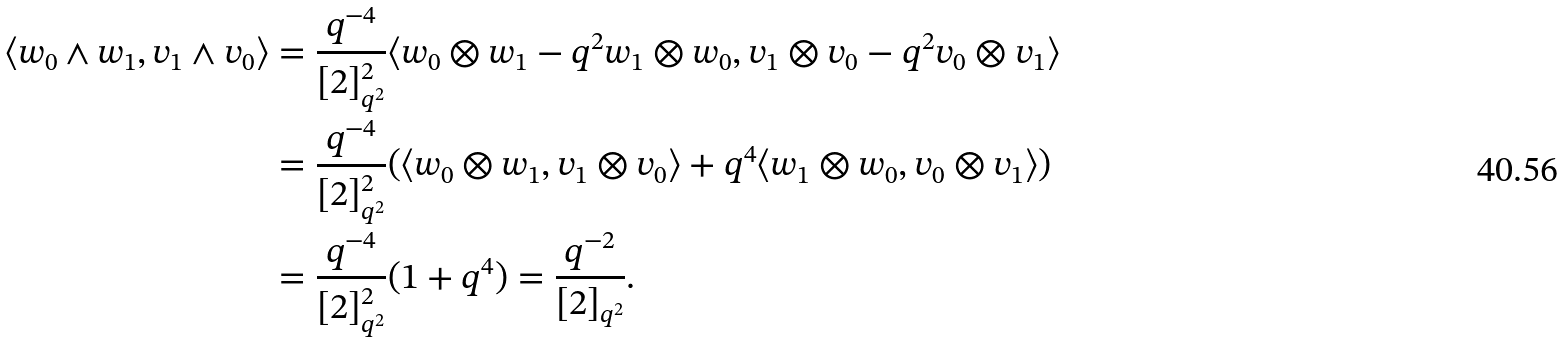<formula> <loc_0><loc_0><loc_500><loc_500>\langle w _ { 0 } \wedge w _ { 1 } , v _ { 1 } \wedge v _ { 0 } \rangle & = \frac { q ^ { - 4 } } { [ 2 ] ^ { 2 } _ { q ^ { 2 } } } \langle w _ { 0 } \otimes w _ { 1 } - q ^ { 2 } w _ { 1 } \otimes w _ { 0 } , v _ { 1 } \otimes v _ { 0 } - q ^ { 2 } v _ { 0 } \otimes v _ { 1 } \rangle \\ & = \frac { q ^ { - 4 } } { [ 2 ] ^ { 2 } _ { q ^ { 2 } } } ( \langle w _ { 0 } \otimes w _ { 1 } , v _ { 1 } \otimes v _ { 0 } \rangle + q ^ { 4 } \langle w _ { 1 } \otimes w _ { 0 } , v _ { 0 } \otimes v _ { 1 } \rangle ) \\ & = \frac { q ^ { - 4 } } { [ 2 ] ^ { 2 } _ { q ^ { 2 } } } ( 1 + q ^ { 4 } ) = \frac { q ^ { - 2 } } { [ 2 ] _ { q ^ { 2 } } } .</formula> 